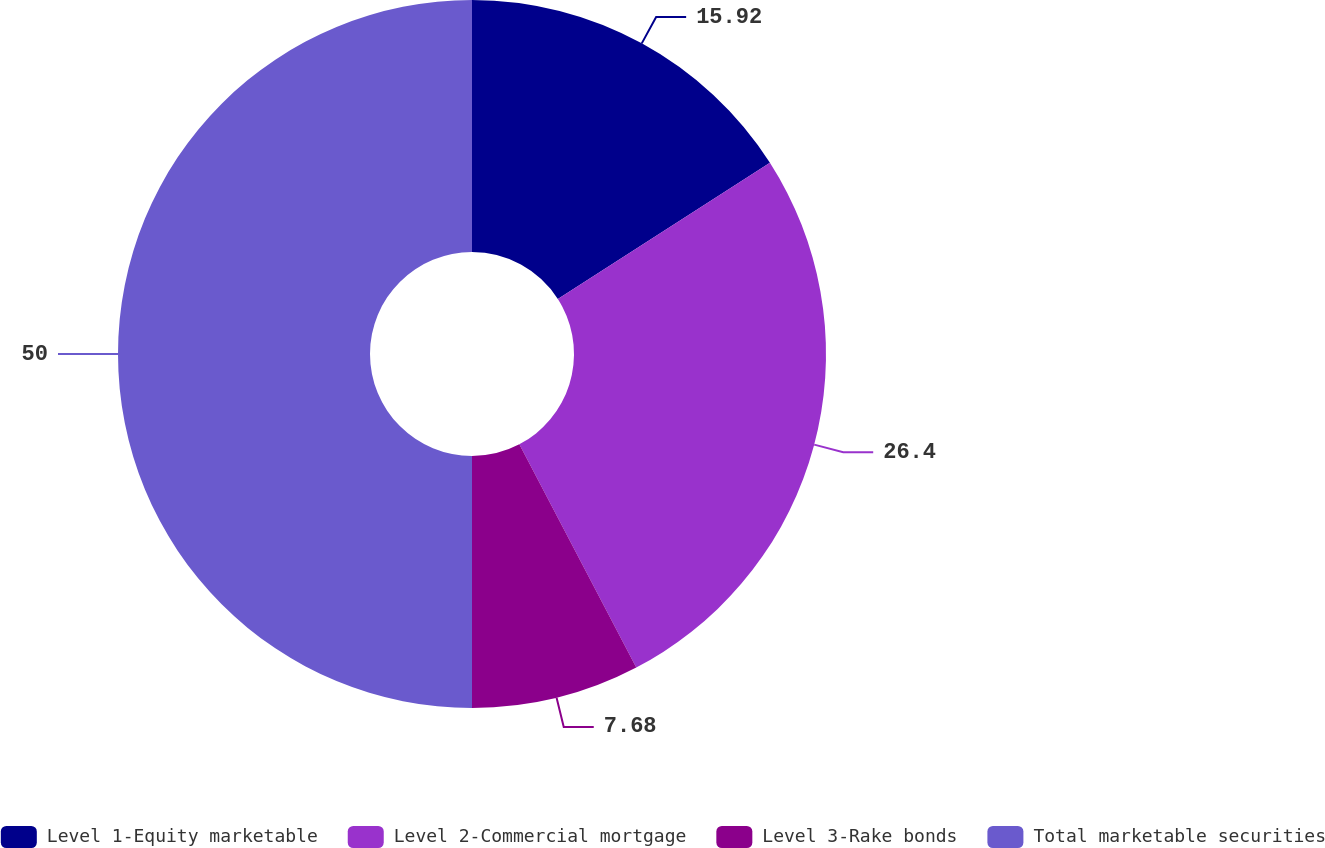Convert chart. <chart><loc_0><loc_0><loc_500><loc_500><pie_chart><fcel>Level 1-Equity marketable<fcel>Level 2-Commercial mortgage<fcel>Level 3-Rake bonds<fcel>Total marketable securities<nl><fcel>15.92%<fcel>26.4%<fcel>7.68%<fcel>50.0%<nl></chart> 